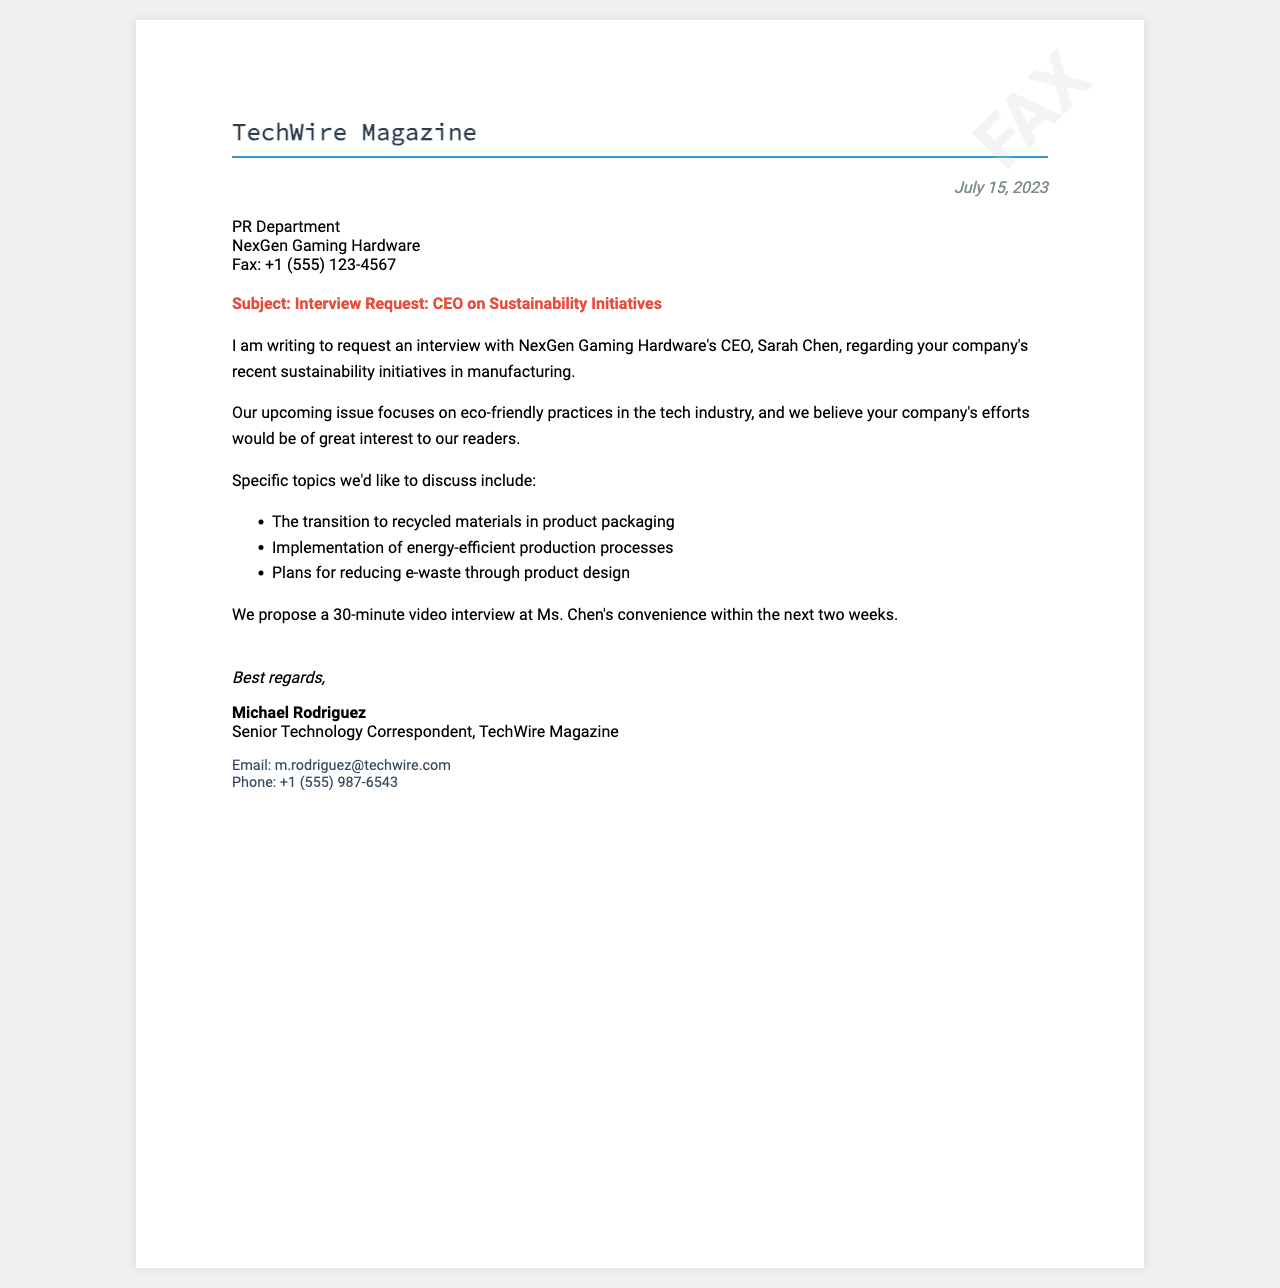What is the name of the magazine requesting the interview? The magazine requesting the interview is mentioned in the letterhead of the fax.
Answer: TechWire Magazine Who is the CEO of NexGen Gaming Hardware? The document states the name of the CEO in the introduction paragraph of the request.
Answer: Sarah Chen What is the date of the fax? The date appears at the top right corner of the document.
Answer: July 15, 2023 What is one of the specific topics the interviewer wants to discuss? The document lists three specific topics in bullet points under the body section.
Answer: Transition to recycled materials in product packaging What is the proposed duration of the interview? The document indicates the length of the interview in the proposal section.
Answer: 30 minutes What is the phone number provided for Michael Rodriguez? The document provides Michael's contact information at the bottom of the fax.
Answer: +1 (555) 987-6543 What is Michael Rodriguez's title? The title of Michael Rodriguez is mentioned right below his name in the closing section.
Answer: Senior Technology Correspondent How will the interview be conducted? Information about the format of the interview is included in the body of the fax.
Answer: Video interview What is the purpose of the upcoming issue of the magazine? The purpose is stated in the second paragraph regarding the magazine’s focus.
Answer: Eco-friendly practices in the tech industry 